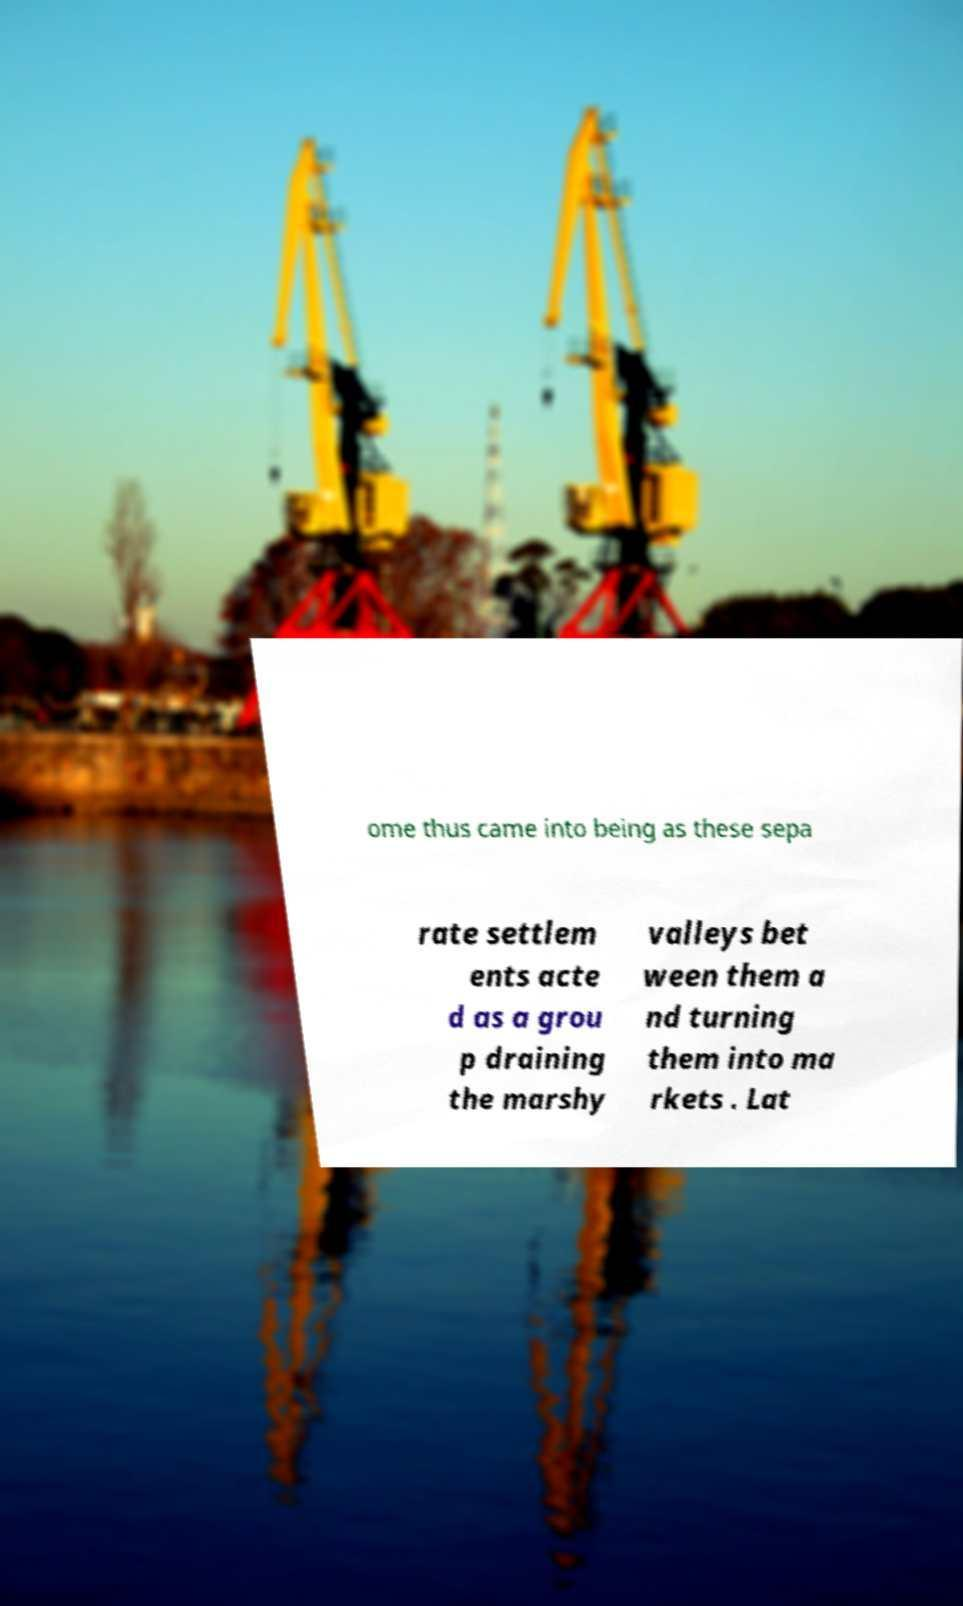Could you assist in decoding the text presented in this image and type it out clearly? ome thus came into being as these sepa rate settlem ents acte d as a grou p draining the marshy valleys bet ween them a nd turning them into ma rkets . Lat 